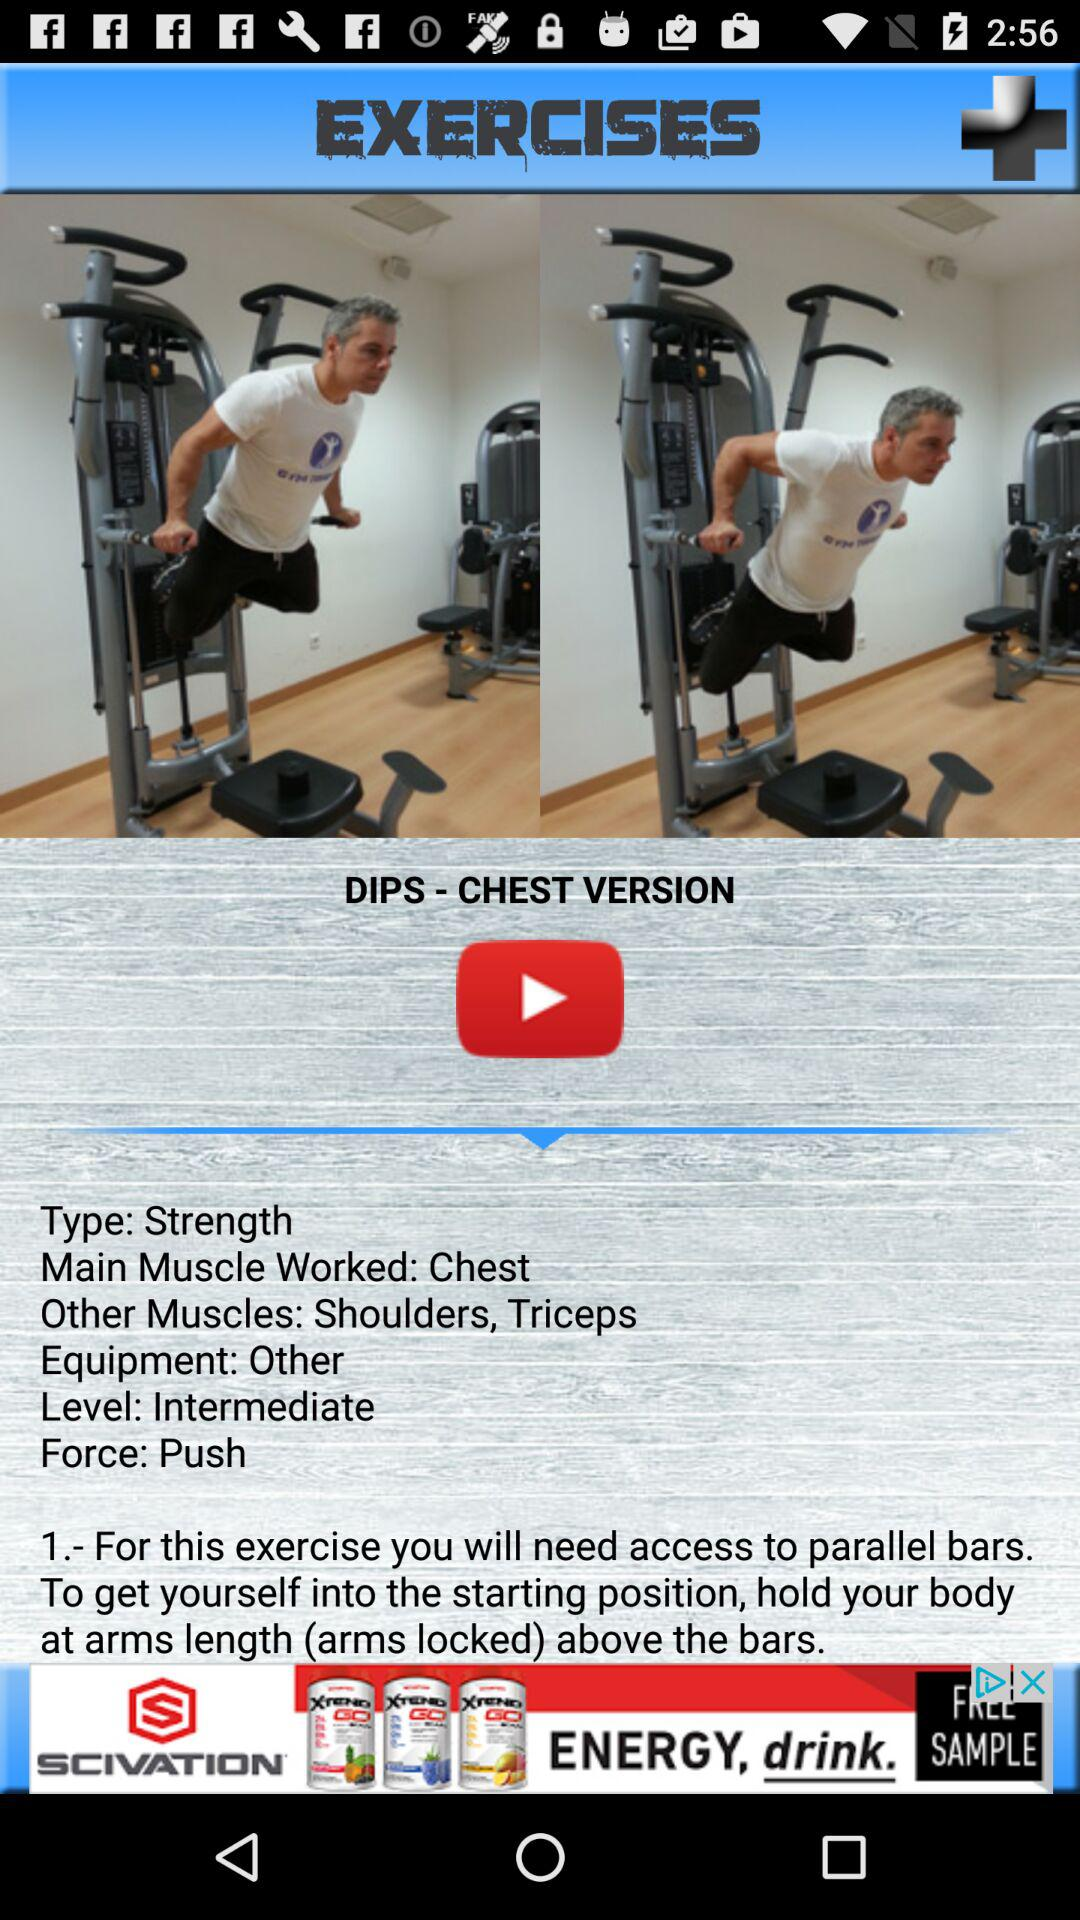What is the given force? The given force is "Push". 